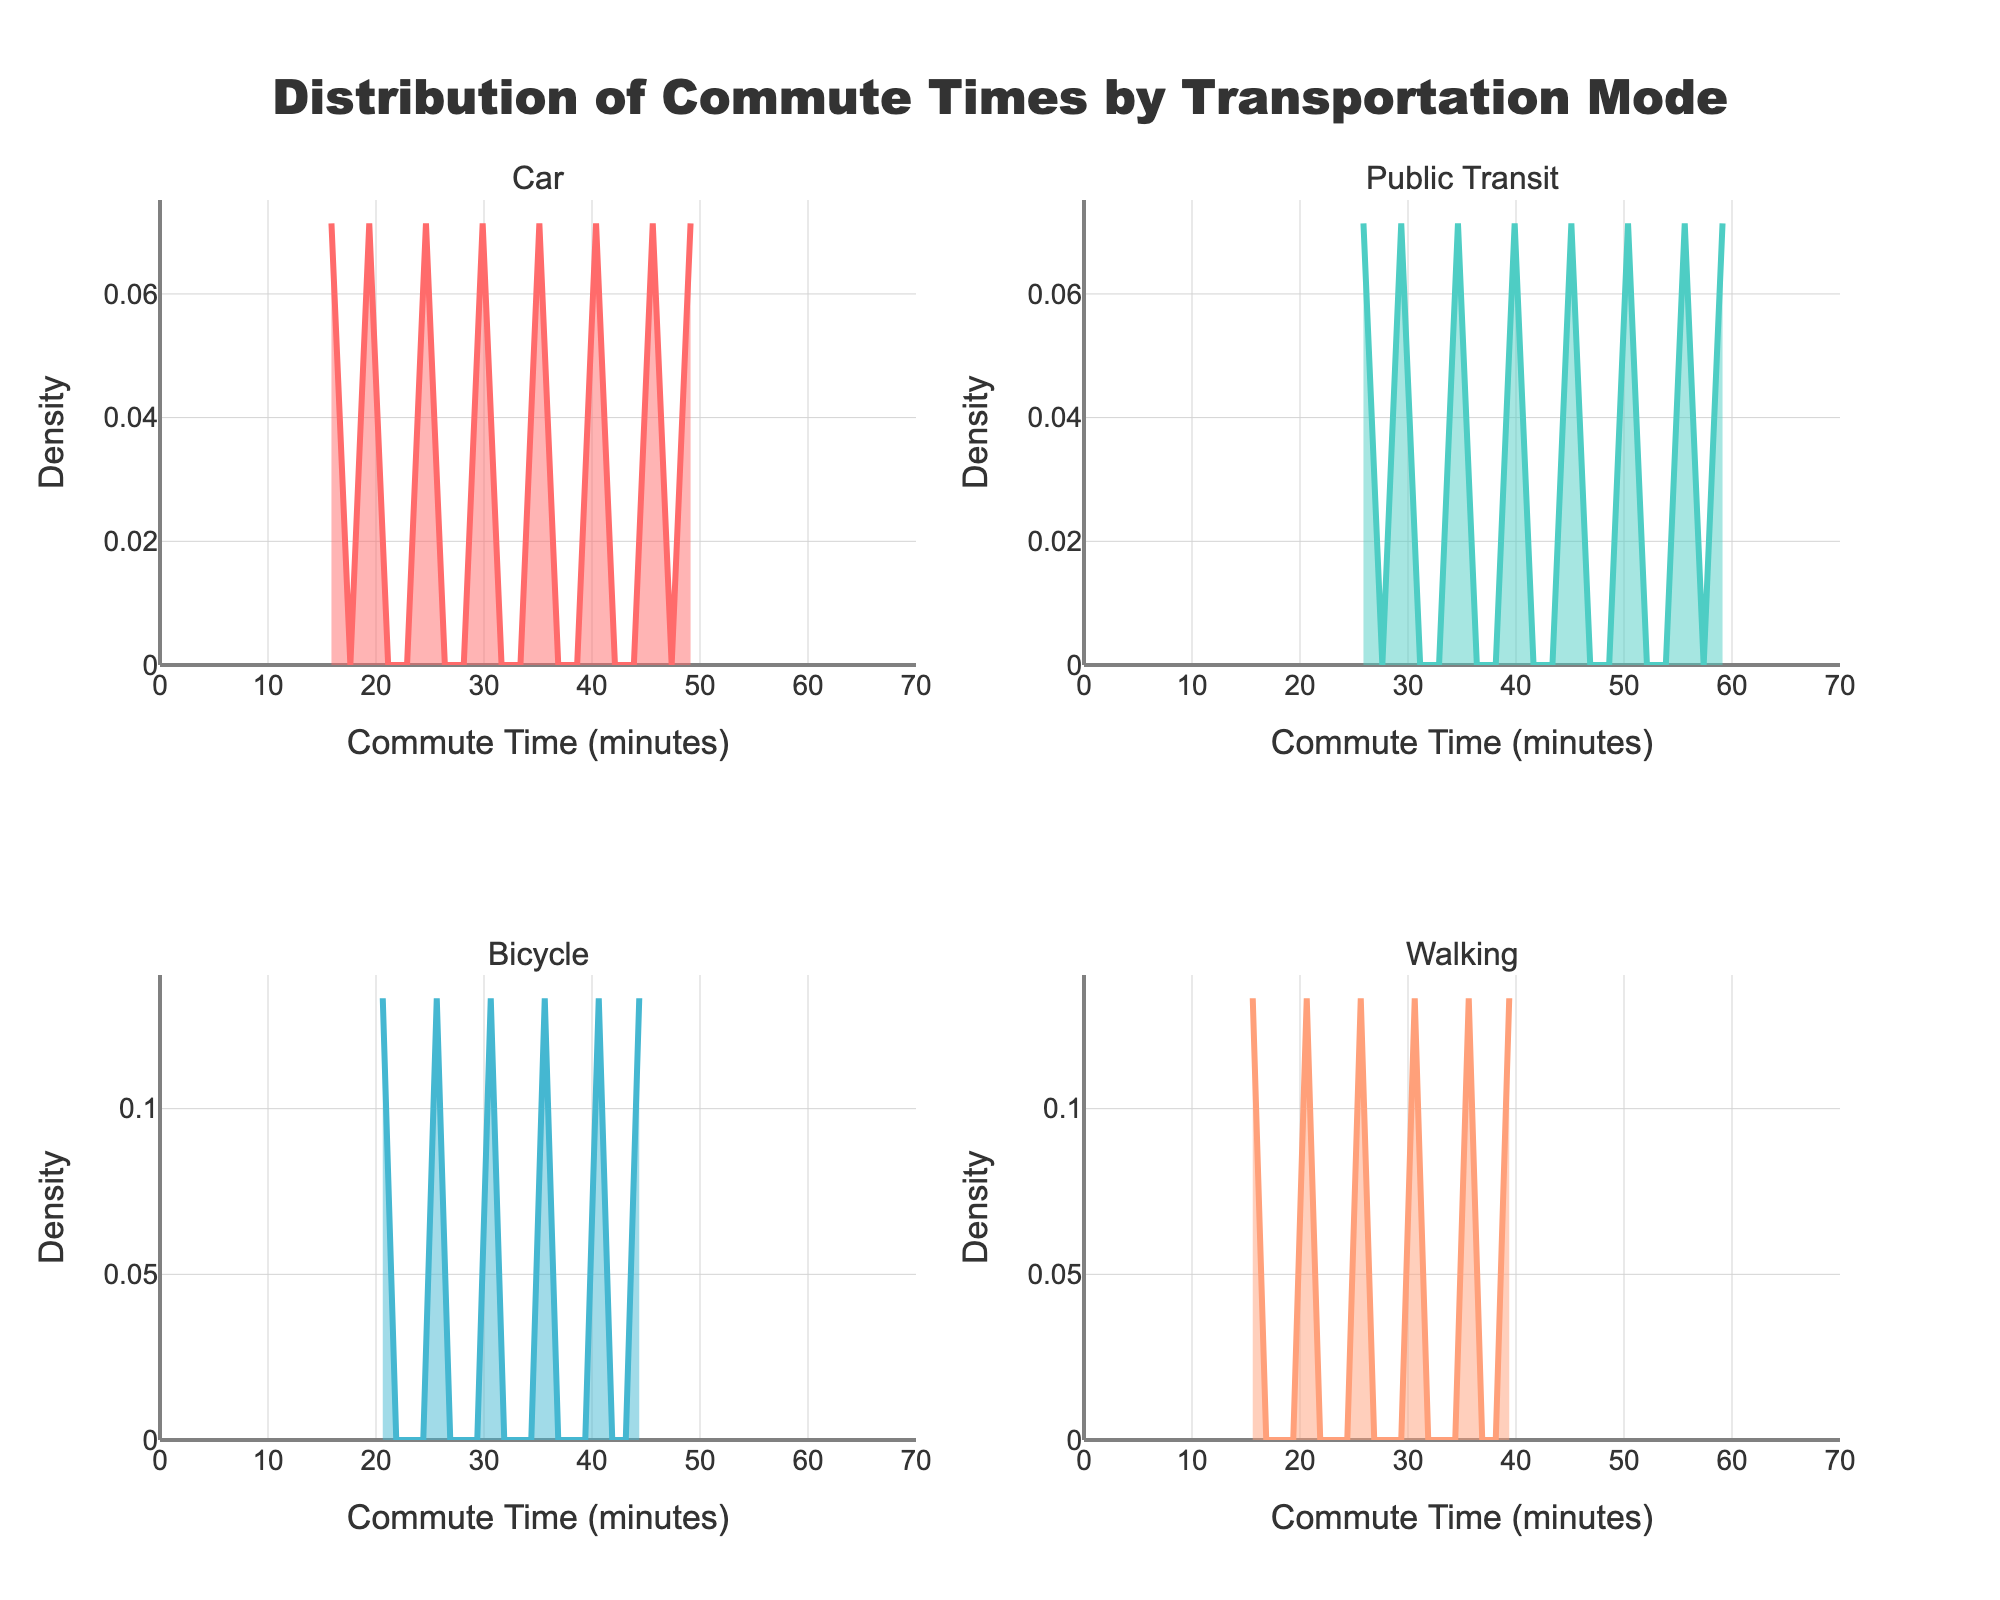What is the title of the figure? The title is typically located at the top of the figure. It provides an overview of what the figure represents, which is "Distribution of Commute Times by Transportation Mode."
Answer: Distribution of Commute Times by Transportation Mode What are the four transportation modes shown in the figure? The figure consists of subplots with titles for each mode, drawn from the dataset provided. These titles indicate the modes: 'Car', 'Public Transit', 'Bicycle', and 'Walking'.
Answer: Car, Public Transit, Bicycle, Walking Which transportation mode has the highest peak in density? By examining the density plots, we identify the highest peak representing the maximum density value. Compare all the plots to find that 'Car' mode has the highest density peak.
Answer: Car What is the approximate range of commute times for cars? To determine the range, observe the x-axis of the 'Car' subplot, noting the minimum and maximum values where the density curve is not zero. The commute times roughly range from 15 to 50 minutes.
Answer: 15 to 50 minutes Which transportation mode has the longest average commute time? Estimate the center of the data distribution for each subplot, where the peak density is highest. The 'Public Transit' subplot shows the highest density extended towards longer commute times.
Answer: Public Transit How do the densities of 'Bicycle' and 'Walking' compare in terms of peak location? Examine the peaks of the 'Bicycle' and 'Walking' density plots. The peak for 'Walking' is at a lower commute time compared to 'Bicycle'.
Answer: Walking has a lower peak location than Bicycle What is the density value at a 30-minute commute for public transit? Locate the 30-minute mark on the x-axis of the 'Public Transit' subplot and follow it vertically to the density curve. The density appears to be around a moderate level.
Answer: Moderate level Between car and public transit, which has a more spread-out distribution? Identify the spread by observing the width of the density plot. 'Public Transit' has a more spread-out (wider) density curve compared to 'Car'.
Answer: Public Transit What is the maximum density value for the Bicycle mode? Look at the highest point on the y-axis in the 'Bicycle' subplot. The peak density value in the bicycle subplot is roughly 0.04.
Answer: 0.04 How do the commute times for walking compare to cycling times in terms of density concentration? Identify where the density is highest for both 'Walking' and 'Bicycle'. 'Walking' has denser commute times concentrated under 30 minutes, while 'Bicycle' is more spread-out over 20 to 40 minutes.
Answer: Walking is more concentrated under 30 minutes, Bicycle over 20-40 minutes 